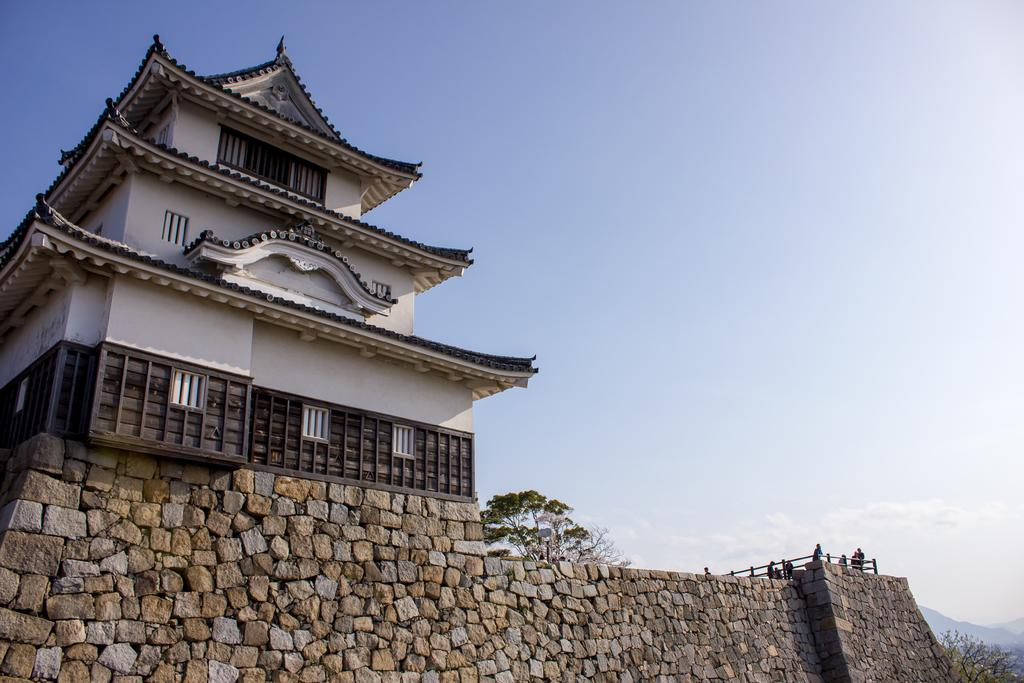What type of house is shown in the image? There is a house with a shed roof in the image. What is in front of the house? There is a granite wall in the front of the house. Are there any people visible in the image? Yes, some persons are standing on the right side of the image. What can be seen at the top of the image? The sky is visible at the top of the image. What type of gold unit can be seen in the image? There is no gold unit present in the image. Is there a joke being told by the persons standing on the right side of the image? There is no indication of a joke being told in the image; the people are simply standing there. 